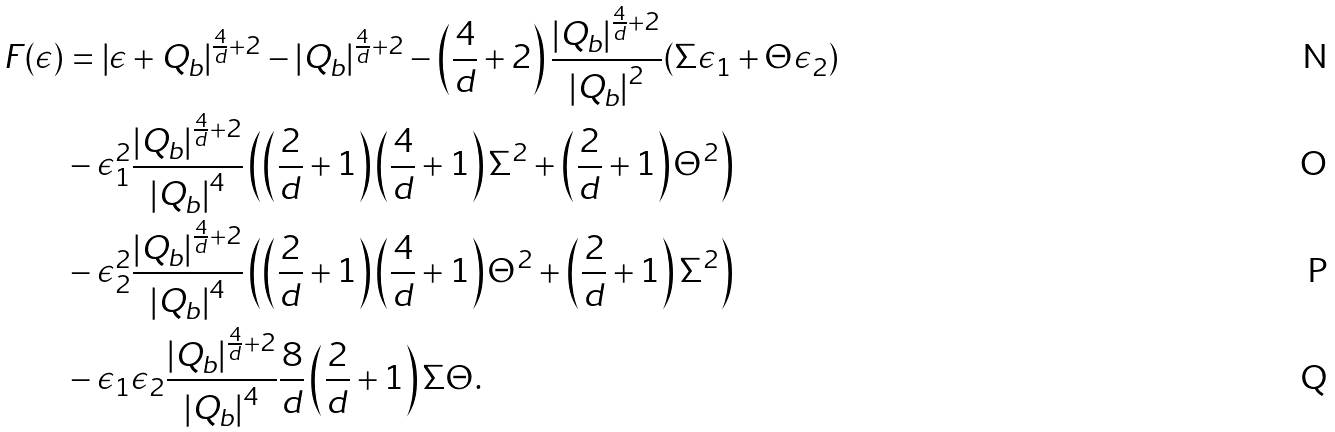<formula> <loc_0><loc_0><loc_500><loc_500>F ( \epsilon ) & = \left | \epsilon + Q _ { b } \right | ^ { \frac { 4 } { d } + 2 } - \left | Q _ { b } \right | ^ { \frac { 4 } { d } + 2 } - \left ( \frac { 4 } { d } + 2 \right ) \frac { \left | Q _ { b } \right | ^ { \frac { 4 } { d } + 2 } } { \left | Q _ { b } \right | ^ { 2 } } ( \Sigma \epsilon _ { 1 } + \Theta \epsilon _ { 2 } ) \\ & - \epsilon _ { 1 } ^ { 2 } \frac { \left | Q _ { b } \right | ^ { \frac { 4 } { d } + 2 } } { \left | Q _ { b } \right | ^ { 4 } } \left ( \left ( \frac { 2 } { d } + 1 \right ) \left ( \frac { 4 } { d } + 1 \right ) \Sigma ^ { 2 } + \left ( \frac { 2 } { d } + 1 \right ) \Theta ^ { 2 } \right ) \\ & - \epsilon _ { 2 } ^ { 2 } \frac { \left | Q _ { b } \right | ^ { \frac { 4 } { d } + 2 } } { \left | Q _ { b } \right | ^ { 4 } } \left ( \left ( \frac { 2 } { d } + 1 \right ) \left ( \frac { 4 } { d } + 1 \right ) \Theta ^ { 2 } + \left ( \frac { 2 } { d } + 1 \right ) \Sigma ^ { 2 } \right ) \\ & - \epsilon _ { 1 } \epsilon _ { 2 } \frac { \left | Q _ { b } \right | ^ { \frac { 4 } { d } + 2 } } { \left | Q _ { b } \right | ^ { 4 } } \frac { 8 } { d } \left ( \frac { 2 } { d } + 1 \right ) \Sigma \Theta .</formula> 